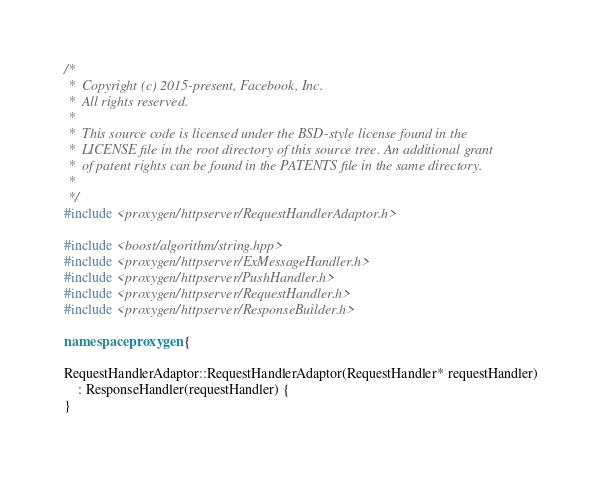Convert code to text. <code><loc_0><loc_0><loc_500><loc_500><_C++_>/*
 *  Copyright (c) 2015-present, Facebook, Inc.
 *  All rights reserved.
 *
 *  This source code is licensed under the BSD-style license found in the
 *  LICENSE file in the root directory of this source tree. An additional grant
 *  of patent rights can be found in the PATENTS file in the same directory.
 *
 */
#include <proxygen/httpserver/RequestHandlerAdaptor.h>

#include <boost/algorithm/string.hpp>
#include <proxygen/httpserver/ExMessageHandler.h>
#include <proxygen/httpserver/PushHandler.h>
#include <proxygen/httpserver/RequestHandler.h>
#include <proxygen/httpserver/ResponseBuilder.h>

namespace proxygen {

RequestHandlerAdaptor::RequestHandlerAdaptor(RequestHandler* requestHandler)
    : ResponseHandler(requestHandler) {
}
</code> 